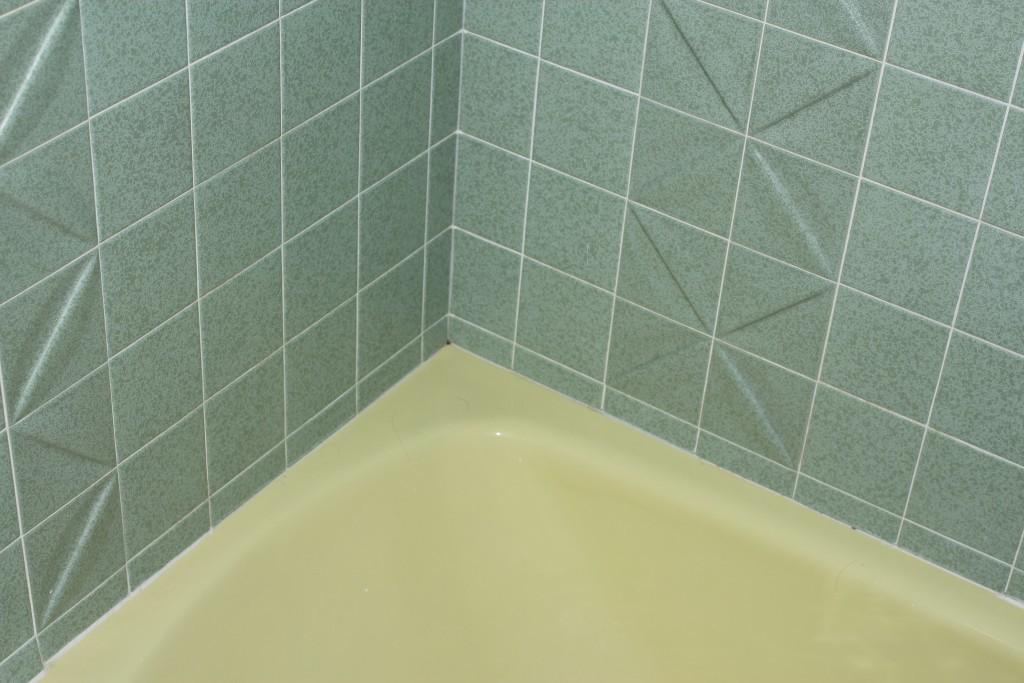Can you describe this image briefly? This is the picture of truncated yellow colored bath tub. And this is the wall with the tiles. 